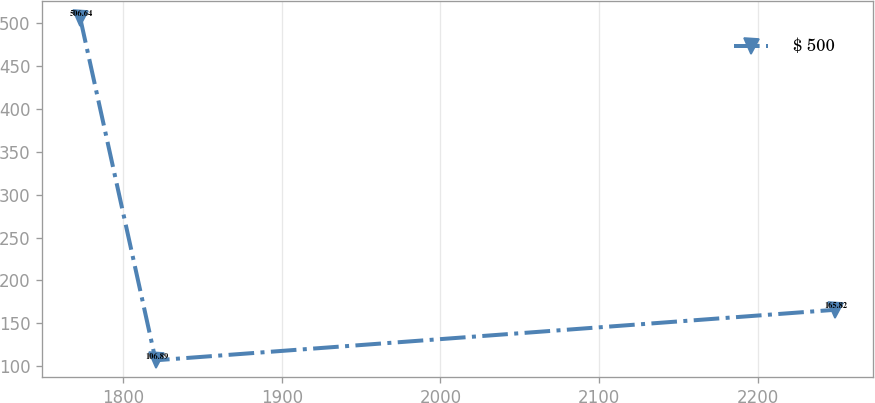<chart> <loc_0><loc_0><loc_500><loc_500><line_chart><ecel><fcel>$ 500<nl><fcel>1772.9<fcel>506.64<nl><fcel>1820.49<fcel>106.89<nl><fcel>2248.77<fcel>165.82<nl></chart> 